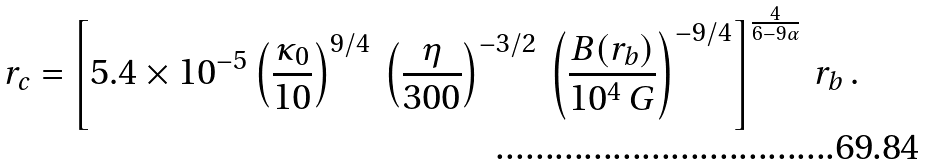<formula> <loc_0><loc_0><loc_500><loc_500>r _ { c } = \left [ 5 . 4 \times 1 0 ^ { - 5 } \left ( \frac { \kappa _ { 0 } } { 1 0 } \right ) ^ { 9 / 4 } \, \left ( \frac { \eta } { 3 0 0 } \right ) ^ { - 3 / 2 } \, \left ( \frac { B ( r _ { b } ) } { 1 0 ^ { 4 } \, G } \right ) ^ { - 9 / 4 } \right ] ^ { \frac { 4 } { 6 - 9 \alpha } } \, r _ { b } \, .</formula> 